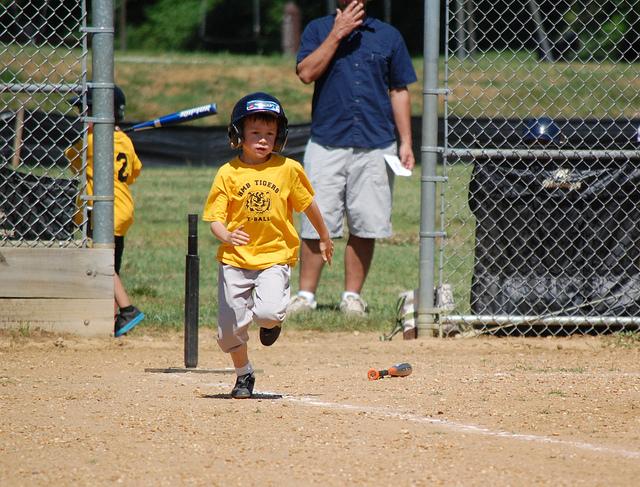Who is behind the plate?
Quick response, please. Boy. What is this child trying to do?
Quick response, please. Run. Did the boy hit the ball?
Keep it brief. Yes. What type of game are they playing?
Concise answer only. Baseball. What color shirt is the boy wearing?
Quick response, please. Yellow. What is the man in the blue shirt doing?
Be succinct. Watching. 